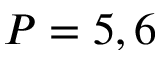Convert formula to latex. <formula><loc_0><loc_0><loc_500><loc_500>P = 5 , 6</formula> 